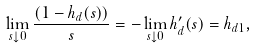<formula> <loc_0><loc_0><loc_500><loc_500>\lim _ { s \downarrow 0 } \frac { ( 1 - h _ { d } ( s ) ) } { s } = - \lim _ { s \downarrow 0 } h ^ { \prime } _ { d } ( s ) = h _ { d 1 } ,</formula> 